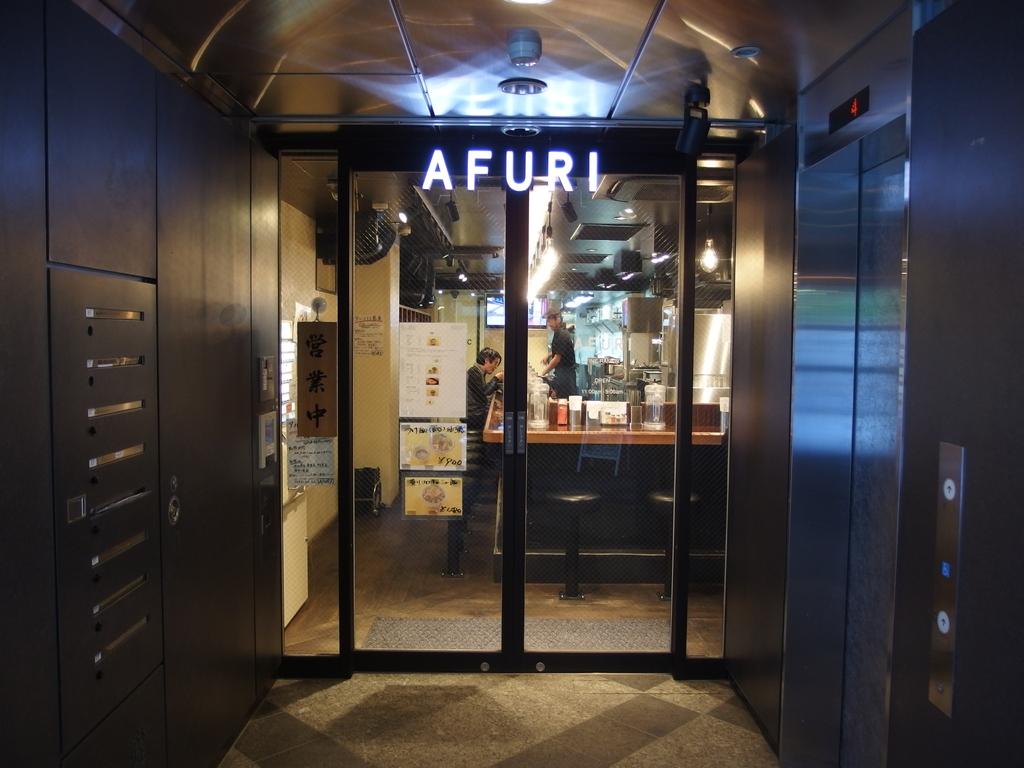What is the name on the door?
Make the answer very short. Afuri. 